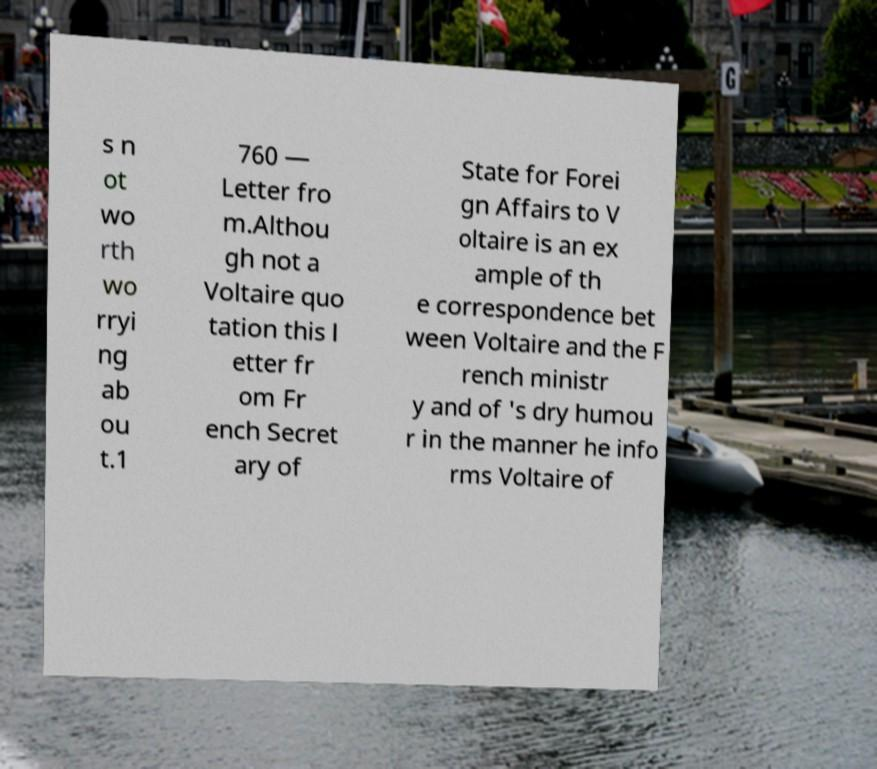I need the written content from this picture converted into text. Can you do that? s n ot wo rth wo rryi ng ab ou t.1 760 — Letter fro m.Althou gh not a Voltaire quo tation this l etter fr om Fr ench Secret ary of State for Forei gn Affairs to V oltaire is an ex ample of th e correspondence bet ween Voltaire and the F rench ministr y and of 's dry humou r in the manner he info rms Voltaire of 